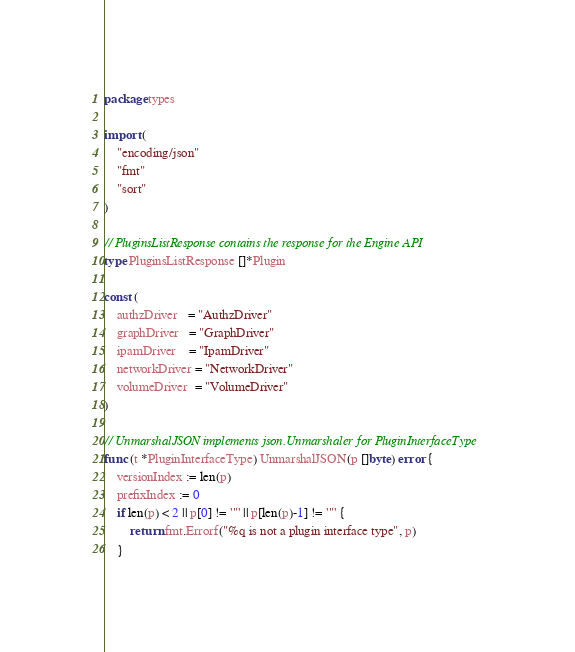Convert code to text. <code><loc_0><loc_0><loc_500><loc_500><_Go_>package types

import (
	"encoding/json"
	"fmt"
	"sort"
)

// PluginsListResponse contains the response for the Engine API
type PluginsListResponse []*Plugin

const (
	authzDriver   = "AuthzDriver"
	graphDriver   = "GraphDriver"
	ipamDriver    = "IpamDriver"
	networkDriver = "NetworkDriver"
	volumeDriver  = "VolumeDriver"
)

// UnmarshalJSON implements json.Unmarshaler for PluginInterfaceType
func (t *PluginInterfaceType) UnmarshalJSON(p []byte) error {
	versionIndex := len(p)
	prefixIndex := 0
	if len(p) < 2 || p[0] != '"' || p[len(p)-1] != '"' {
		return fmt.Errorf("%q is not a plugin interface type", p)
	}</code> 